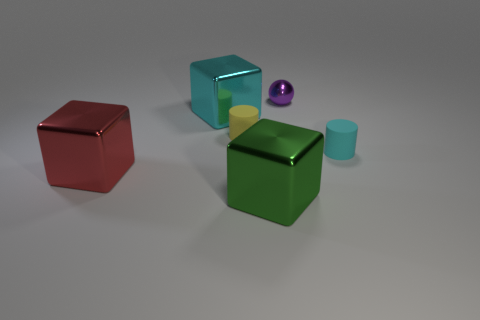There is a ball that is the same material as the big green thing; what is its color?
Your answer should be compact. Purple. Are there fewer cyan cylinders that are behind the cyan metal block than cyan matte cylinders that are in front of the green metal block?
Give a very brief answer. No. How many blocks have the same color as the tiny sphere?
Keep it short and to the point. 0. How many tiny matte cylinders are to the right of the large green cube and behind the small cyan rubber thing?
Your response must be concise. 0. There is a yellow thing that is to the left of the cyan object that is to the right of the purple metallic object; what is its material?
Your answer should be compact. Rubber. Is there a cyan cylinder made of the same material as the tiny purple ball?
Offer a very short reply. No. There is a yellow object that is the same size as the purple thing; what is it made of?
Provide a succinct answer. Rubber. How big is the cyan object that is in front of the large cube behind the rubber cylinder behind the cyan cylinder?
Ensure brevity in your answer.  Small. There is a metallic block behind the tiny yellow matte cylinder; are there any cyan metallic things behind it?
Offer a terse response. No. Do the cyan rubber thing and the metal object on the right side of the large green shiny object have the same shape?
Offer a terse response. No. 